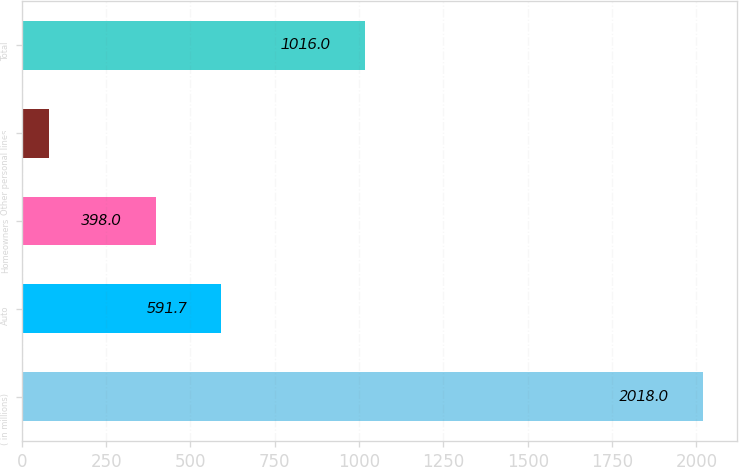<chart> <loc_0><loc_0><loc_500><loc_500><bar_chart><fcel>( in millions)<fcel>Auto<fcel>Homeowners<fcel>Other personal lines<fcel>Total<nl><fcel>2018<fcel>591.7<fcel>398<fcel>81<fcel>1016<nl></chart> 